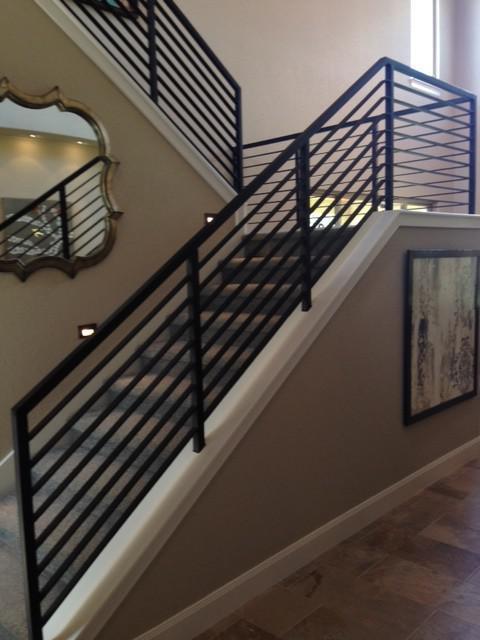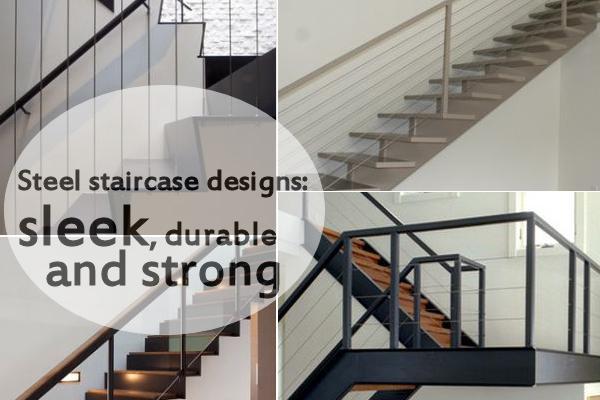The first image is the image on the left, the second image is the image on the right. Analyze the images presented: Is the assertion "There is at least one staircase with horizontal railings." valid? Answer yes or no. Yes. 